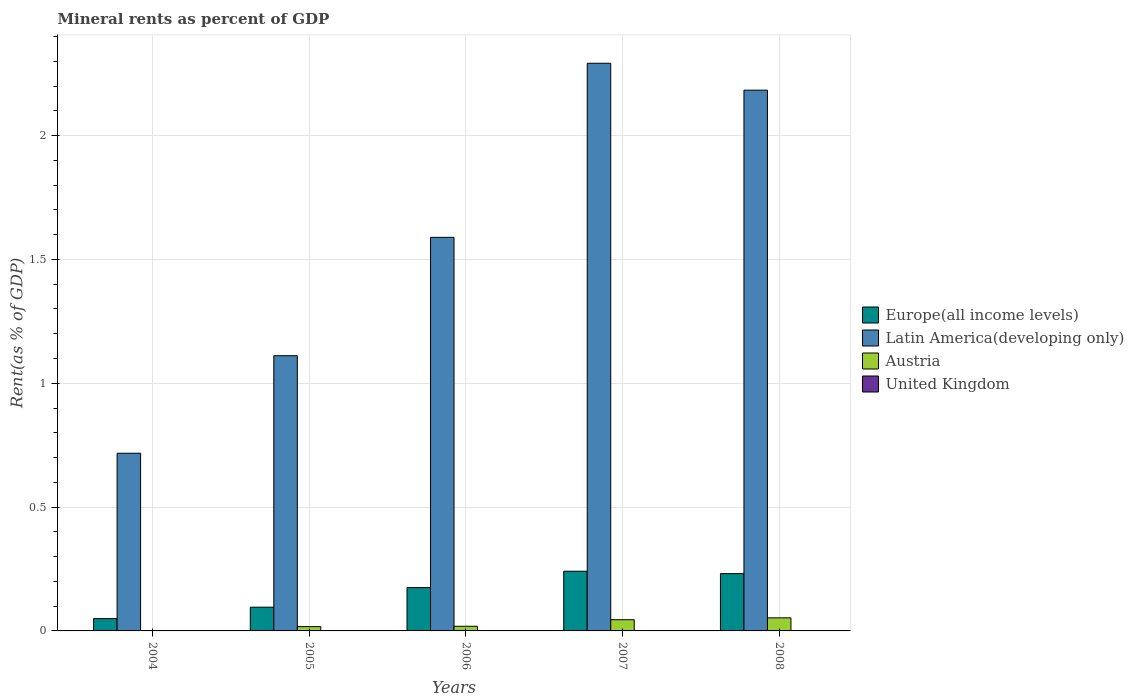How many groups of bars are there?
Give a very brief answer. 5. Are the number of bars on each tick of the X-axis equal?
Provide a succinct answer. Yes. How many bars are there on the 4th tick from the left?
Make the answer very short. 4. How many bars are there on the 2nd tick from the right?
Provide a succinct answer. 4. What is the label of the 4th group of bars from the left?
Provide a succinct answer. 2007. What is the mineral rent in Austria in 2004?
Provide a short and direct response. 0. Across all years, what is the maximum mineral rent in United Kingdom?
Give a very brief answer. 0. Across all years, what is the minimum mineral rent in Latin America(developing only)?
Your answer should be compact. 0.72. In which year was the mineral rent in Latin America(developing only) maximum?
Your answer should be compact. 2007. What is the total mineral rent in Austria in the graph?
Offer a very short reply. 0.13. What is the difference between the mineral rent in United Kingdom in 2005 and that in 2008?
Your answer should be very brief. -0. What is the difference between the mineral rent in United Kingdom in 2008 and the mineral rent in Latin America(developing only) in 2004?
Offer a very short reply. -0.72. What is the average mineral rent in United Kingdom per year?
Your answer should be very brief. 3.6004656542504624e-5. In the year 2007, what is the difference between the mineral rent in Europe(all income levels) and mineral rent in Latin America(developing only)?
Make the answer very short. -2.05. What is the ratio of the mineral rent in Latin America(developing only) in 2004 to that in 2006?
Offer a terse response. 0.45. What is the difference between the highest and the second highest mineral rent in Europe(all income levels)?
Provide a succinct answer. 0.01. What is the difference between the highest and the lowest mineral rent in Europe(all income levels)?
Offer a terse response. 0.19. Is the sum of the mineral rent in United Kingdom in 2004 and 2005 greater than the maximum mineral rent in Europe(all income levels) across all years?
Make the answer very short. No. What does the 1st bar from the left in 2008 represents?
Your response must be concise. Europe(all income levels). What does the 4th bar from the right in 2006 represents?
Offer a terse response. Europe(all income levels). How many bars are there?
Provide a succinct answer. 20. How many years are there in the graph?
Your answer should be very brief. 5. Are the values on the major ticks of Y-axis written in scientific E-notation?
Provide a short and direct response. No. Does the graph contain any zero values?
Your response must be concise. No. Where does the legend appear in the graph?
Make the answer very short. Center right. How many legend labels are there?
Your response must be concise. 4. How are the legend labels stacked?
Offer a terse response. Vertical. What is the title of the graph?
Provide a short and direct response. Mineral rents as percent of GDP. Does "Australia" appear as one of the legend labels in the graph?
Offer a terse response. No. What is the label or title of the X-axis?
Your answer should be very brief. Years. What is the label or title of the Y-axis?
Offer a very short reply. Rent(as % of GDP). What is the Rent(as % of GDP) of Europe(all income levels) in 2004?
Ensure brevity in your answer.  0.05. What is the Rent(as % of GDP) in Latin America(developing only) in 2004?
Your response must be concise. 0.72. What is the Rent(as % of GDP) of Austria in 2004?
Make the answer very short. 0. What is the Rent(as % of GDP) of United Kingdom in 2004?
Provide a succinct answer. 6.19596915094659e-6. What is the Rent(as % of GDP) in Europe(all income levels) in 2005?
Ensure brevity in your answer.  0.1. What is the Rent(as % of GDP) of Latin America(developing only) in 2005?
Give a very brief answer. 1.11. What is the Rent(as % of GDP) in Austria in 2005?
Provide a short and direct response. 0.02. What is the Rent(as % of GDP) in United Kingdom in 2005?
Your answer should be very brief. 7.34291393954371e-6. What is the Rent(as % of GDP) in Europe(all income levels) in 2006?
Your answer should be very brief. 0.18. What is the Rent(as % of GDP) of Latin America(developing only) in 2006?
Make the answer very short. 1.59. What is the Rent(as % of GDP) of Austria in 2006?
Make the answer very short. 0.02. What is the Rent(as % of GDP) of United Kingdom in 2006?
Make the answer very short. 1.26189468360093e-5. What is the Rent(as % of GDP) in Europe(all income levels) in 2007?
Offer a terse response. 0.24. What is the Rent(as % of GDP) of Latin America(developing only) in 2007?
Your answer should be very brief. 2.29. What is the Rent(as % of GDP) in Austria in 2007?
Your answer should be very brief. 0.05. What is the Rent(as % of GDP) of United Kingdom in 2007?
Offer a terse response. 3.21125777650235e-5. What is the Rent(as % of GDP) in Europe(all income levels) in 2008?
Ensure brevity in your answer.  0.23. What is the Rent(as % of GDP) in Latin America(developing only) in 2008?
Your answer should be very brief. 2.18. What is the Rent(as % of GDP) in Austria in 2008?
Keep it short and to the point. 0.05. What is the Rent(as % of GDP) of United Kingdom in 2008?
Your answer should be compact. 0. Across all years, what is the maximum Rent(as % of GDP) of Europe(all income levels)?
Offer a terse response. 0.24. Across all years, what is the maximum Rent(as % of GDP) of Latin America(developing only)?
Your response must be concise. 2.29. Across all years, what is the maximum Rent(as % of GDP) of Austria?
Your answer should be compact. 0.05. Across all years, what is the maximum Rent(as % of GDP) of United Kingdom?
Make the answer very short. 0. Across all years, what is the minimum Rent(as % of GDP) of Europe(all income levels)?
Offer a very short reply. 0.05. Across all years, what is the minimum Rent(as % of GDP) in Latin America(developing only)?
Offer a very short reply. 0.72. Across all years, what is the minimum Rent(as % of GDP) in Austria?
Ensure brevity in your answer.  0. Across all years, what is the minimum Rent(as % of GDP) of United Kingdom?
Keep it short and to the point. 6.19596915094659e-6. What is the total Rent(as % of GDP) of Europe(all income levels) in the graph?
Make the answer very short. 0.79. What is the total Rent(as % of GDP) in Latin America(developing only) in the graph?
Your answer should be very brief. 7.89. What is the total Rent(as % of GDP) of Austria in the graph?
Your answer should be compact. 0.13. What is the difference between the Rent(as % of GDP) in Europe(all income levels) in 2004 and that in 2005?
Offer a very short reply. -0.05. What is the difference between the Rent(as % of GDP) of Latin America(developing only) in 2004 and that in 2005?
Offer a very short reply. -0.39. What is the difference between the Rent(as % of GDP) of Austria in 2004 and that in 2005?
Provide a succinct answer. -0.02. What is the difference between the Rent(as % of GDP) of Europe(all income levels) in 2004 and that in 2006?
Offer a very short reply. -0.13. What is the difference between the Rent(as % of GDP) of Latin America(developing only) in 2004 and that in 2006?
Your response must be concise. -0.87. What is the difference between the Rent(as % of GDP) in Austria in 2004 and that in 2006?
Your answer should be compact. -0.02. What is the difference between the Rent(as % of GDP) of United Kingdom in 2004 and that in 2006?
Your response must be concise. -0. What is the difference between the Rent(as % of GDP) of Europe(all income levels) in 2004 and that in 2007?
Give a very brief answer. -0.19. What is the difference between the Rent(as % of GDP) of Latin America(developing only) in 2004 and that in 2007?
Offer a very short reply. -1.57. What is the difference between the Rent(as % of GDP) in Austria in 2004 and that in 2007?
Give a very brief answer. -0.04. What is the difference between the Rent(as % of GDP) in United Kingdom in 2004 and that in 2007?
Provide a succinct answer. -0. What is the difference between the Rent(as % of GDP) of Europe(all income levels) in 2004 and that in 2008?
Your answer should be compact. -0.18. What is the difference between the Rent(as % of GDP) in Latin America(developing only) in 2004 and that in 2008?
Your answer should be compact. -1.47. What is the difference between the Rent(as % of GDP) in Austria in 2004 and that in 2008?
Your response must be concise. -0.05. What is the difference between the Rent(as % of GDP) in United Kingdom in 2004 and that in 2008?
Provide a short and direct response. -0. What is the difference between the Rent(as % of GDP) of Europe(all income levels) in 2005 and that in 2006?
Your answer should be very brief. -0.08. What is the difference between the Rent(as % of GDP) in Latin America(developing only) in 2005 and that in 2006?
Offer a very short reply. -0.48. What is the difference between the Rent(as % of GDP) in Austria in 2005 and that in 2006?
Your answer should be very brief. -0. What is the difference between the Rent(as % of GDP) in Europe(all income levels) in 2005 and that in 2007?
Offer a terse response. -0.15. What is the difference between the Rent(as % of GDP) in Latin America(developing only) in 2005 and that in 2007?
Your answer should be very brief. -1.18. What is the difference between the Rent(as % of GDP) of Austria in 2005 and that in 2007?
Ensure brevity in your answer.  -0.03. What is the difference between the Rent(as % of GDP) in Europe(all income levels) in 2005 and that in 2008?
Your answer should be compact. -0.14. What is the difference between the Rent(as % of GDP) in Latin America(developing only) in 2005 and that in 2008?
Provide a succinct answer. -1.07. What is the difference between the Rent(as % of GDP) of Austria in 2005 and that in 2008?
Your answer should be compact. -0.04. What is the difference between the Rent(as % of GDP) in United Kingdom in 2005 and that in 2008?
Ensure brevity in your answer.  -0. What is the difference between the Rent(as % of GDP) in Europe(all income levels) in 2006 and that in 2007?
Provide a succinct answer. -0.07. What is the difference between the Rent(as % of GDP) in Latin America(developing only) in 2006 and that in 2007?
Offer a very short reply. -0.7. What is the difference between the Rent(as % of GDP) of Austria in 2006 and that in 2007?
Offer a very short reply. -0.03. What is the difference between the Rent(as % of GDP) in Europe(all income levels) in 2006 and that in 2008?
Give a very brief answer. -0.06. What is the difference between the Rent(as % of GDP) of Latin America(developing only) in 2006 and that in 2008?
Ensure brevity in your answer.  -0.59. What is the difference between the Rent(as % of GDP) in Austria in 2006 and that in 2008?
Ensure brevity in your answer.  -0.03. What is the difference between the Rent(as % of GDP) of United Kingdom in 2006 and that in 2008?
Provide a succinct answer. -0. What is the difference between the Rent(as % of GDP) in Europe(all income levels) in 2007 and that in 2008?
Offer a very short reply. 0.01. What is the difference between the Rent(as % of GDP) in Latin America(developing only) in 2007 and that in 2008?
Provide a short and direct response. 0.11. What is the difference between the Rent(as % of GDP) of Austria in 2007 and that in 2008?
Provide a succinct answer. -0.01. What is the difference between the Rent(as % of GDP) of United Kingdom in 2007 and that in 2008?
Give a very brief answer. -0. What is the difference between the Rent(as % of GDP) in Europe(all income levels) in 2004 and the Rent(as % of GDP) in Latin America(developing only) in 2005?
Ensure brevity in your answer.  -1.06. What is the difference between the Rent(as % of GDP) of Europe(all income levels) in 2004 and the Rent(as % of GDP) of Austria in 2005?
Offer a very short reply. 0.03. What is the difference between the Rent(as % of GDP) of Europe(all income levels) in 2004 and the Rent(as % of GDP) of United Kingdom in 2005?
Provide a succinct answer. 0.05. What is the difference between the Rent(as % of GDP) of Latin America(developing only) in 2004 and the Rent(as % of GDP) of Austria in 2005?
Your answer should be compact. 0.7. What is the difference between the Rent(as % of GDP) in Latin America(developing only) in 2004 and the Rent(as % of GDP) in United Kingdom in 2005?
Provide a short and direct response. 0.72. What is the difference between the Rent(as % of GDP) in Europe(all income levels) in 2004 and the Rent(as % of GDP) in Latin America(developing only) in 2006?
Keep it short and to the point. -1.54. What is the difference between the Rent(as % of GDP) of Europe(all income levels) in 2004 and the Rent(as % of GDP) of Austria in 2006?
Ensure brevity in your answer.  0.03. What is the difference between the Rent(as % of GDP) in Europe(all income levels) in 2004 and the Rent(as % of GDP) in United Kingdom in 2006?
Offer a very short reply. 0.05. What is the difference between the Rent(as % of GDP) of Latin America(developing only) in 2004 and the Rent(as % of GDP) of Austria in 2006?
Your response must be concise. 0.7. What is the difference between the Rent(as % of GDP) in Latin America(developing only) in 2004 and the Rent(as % of GDP) in United Kingdom in 2006?
Keep it short and to the point. 0.72. What is the difference between the Rent(as % of GDP) in Europe(all income levels) in 2004 and the Rent(as % of GDP) in Latin America(developing only) in 2007?
Your answer should be very brief. -2.24. What is the difference between the Rent(as % of GDP) in Europe(all income levels) in 2004 and the Rent(as % of GDP) in Austria in 2007?
Offer a terse response. 0. What is the difference between the Rent(as % of GDP) of Europe(all income levels) in 2004 and the Rent(as % of GDP) of United Kingdom in 2007?
Offer a very short reply. 0.05. What is the difference between the Rent(as % of GDP) in Latin America(developing only) in 2004 and the Rent(as % of GDP) in Austria in 2007?
Give a very brief answer. 0.67. What is the difference between the Rent(as % of GDP) of Latin America(developing only) in 2004 and the Rent(as % of GDP) of United Kingdom in 2007?
Keep it short and to the point. 0.72. What is the difference between the Rent(as % of GDP) in Europe(all income levels) in 2004 and the Rent(as % of GDP) in Latin America(developing only) in 2008?
Your answer should be compact. -2.13. What is the difference between the Rent(as % of GDP) of Europe(all income levels) in 2004 and the Rent(as % of GDP) of Austria in 2008?
Keep it short and to the point. -0. What is the difference between the Rent(as % of GDP) in Europe(all income levels) in 2004 and the Rent(as % of GDP) in United Kingdom in 2008?
Ensure brevity in your answer.  0.05. What is the difference between the Rent(as % of GDP) in Latin America(developing only) in 2004 and the Rent(as % of GDP) in Austria in 2008?
Your response must be concise. 0.66. What is the difference between the Rent(as % of GDP) of Latin America(developing only) in 2004 and the Rent(as % of GDP) of United Kingdom in 2008?
Your answer should be very brief. 0.72. What is the difference between the Rent(as % of GDP) in Austria in 2004 and the Rent(as % of GDP) in United Kingdom in 2008?
Ensure brevity in your answer.  0. What is the difference between the Rent(as % of GDP) in Europe(all income levels) in 2005 and the Rent(as % of GDP) in Latin America(developing only) in 2006?
Offer a terse response. -1.49. What is the difference between the Rent(as % of GDP) of Europe(all income levels) in 2005 and the Rent(as % of GDP) of Austria in 2006?
Ensure brevity in your answer.  0.08. What is the difference between the Rent(as % of GDP) of Europe(all income levels) in 2005 and the Rent(as % of GDP) of United Kingdom in 2006?
Provide a succinct answer. 0.1. What is the difference between the Rent(as % of GDP) in Latin America(developing only) in 2005 and the Rent(as % of GDP) in Austria in 2006?
Keep it short and to the point. 1.09. What is the difference between the Rent(as % of GDP) of Latin America(developing only) in 2005 and the Rent(as % of GDP) of United Kingdom in 2006?
Provide a succinct answer. 1.11. What is the difference between the Rent(as % of GDP) in Austria in 2005 and the Rent(as % of GDP) in United Kingdom in 2006?
Your response must be concise. 0.02. What is the difference between the Rent(as % of GDP) of Europe(all income levels) in 2005 and the Rent(as % of GDP) of Latin America(developing only) in 2007?
Keep it short and to the point. -2.2. What is the difference between the Rent(as % of GDP) in Europe(all income levels) in 2005 and the Rent(as % of GDP) in Austria in 2007?
Keep it short and to the point. 0.05. What is the difference between the Rent(as % of GDP) of Europe(all income levels) in 2005 and the Rent(as % of GDP) of United Kingdom in 2007?
Provide a succinct answer. 0.1. What is the difference between the Rent(as % of GDP) of Latin America(developing only) in 2005 and the Rent(as % of GDP) of Austria in 2007?
Your response must be concise. 1.07. What is the difference between the Rent(as % of GDP) of Latin America(developing only) in 2005 and the Rent(as % of GDP) of United Kingdom in 2007?
Provide a succinct answer. 1.11. What is the difference between the Rent(as % of GDP) in Austria in 2005 and the Rent(as % of GDP) in United Kingdom in 2007?
Offer a terse response. 0.02. What is the difference between the Rent(as % of GDP) of Europe(all income levels) in 2005 and the Rent(as % of GDP) of Latin America(developing only) in 2008?
Offer a very short reply. -2.09. What is the difference between the Rent(as % of GDP) in Europe(all income levels) in 2005 and the Rent(as % of GDP) in Austria in 2008?
Give a very brief answer. 0.04. What is the difference between the Rent(as % of GDP) of Europe(all income levels) in 2005 and the Rent(as % of GDP) of United Kingdom in 2008?
Make the answer very short. 0.1. What is the difference between the Rent(as % of GDP) in Latin America(developing only) in 2005 and the Rent(as % of GDP) in Austria in 2008?
Provide a succinct answer. 1.06. What is the difference between the Rent(as % of GDP) of Austria in 2005 and the Rent(as % of GDP) of United Kingdom in 2008?
Offer a terse response. 0.02. What is the difference between the Rent(as % of GDP) in Europe(all income levels) in 2006 and the Rent(as % of GDP) in Latin America(developing only) in 2007?
Offer a terse response. -2.12. What is the difference between the Rent(as % of GDP) in Europe(all income levels) in 2006 and the Rent(as % of GDP) in Austria in 2007?
Give a very brief answer. 0.13. What is the difference between the Rent(as % of GDP) in Europe(all income levels) in 2006 and the Rent(as % of GDP) in United Kingdom in 2007?
Offer a very short reply. 0.17. What is the difference between the Rent(as % of GDP) of Latin America(developing only) in 2006 and the Rent(as % of GDP) of Austria in 2007?
Offer a very short reply. 1.54. What is the difference between the Rent(as % of GDP) in Latin America(developing only) in 2006 and the Rent(as % of GDP) in United Kingdom in 2007?
Offer a terse response. 1.59. What is the difference between the Rent(as % of GDP) in Austria in 2006 and the Rent(as % of GDP) in United Kingdom in 2007?
Keep it short and to the point. 0.02. What is the difference between the Rent(as % of GDP) of Europe(all income levels) in 2006 and the Rent(as % of GDP) of Latin America(developing only) in 2008?
Your answer should be compact. -2.01. What is the difference between the Rent(as % of GDP) of Europe(all income levels) in 2006 and the Rent(as % of GDP) of Austria in 2008?
Make the answer very short. 0.12. What is the difference between the Rent(as % of GDP) of Europe(all income levels) in 2006 and the Rent(as % of GDP) of United Kingdom in 2008?
Provide a succinct answer. 0.17. What is the difference between the Rent(as % of GDP) in Latin America(developing only) in 2006 and the Rent(as % of GDP) in Austria in 2008?
Your response must be concise. 1.54. What is the difference between the Rent(as % of GDP) in Latin America(developing only) in 2006 and the Rent(as % of GDP) in United Kingdom in 2008?
Offer a very short reply. 1.59. What is the difference between the Rent(as % of GDP) of Austria in 2006 and the Rent(as % of GDP) of United Kingdom in 2008?
Ensure brevity in your answer.  0.02. What is the difference between the Rent(as % of GDP) of Europe(all income levels) in 2007 and the Rent(as % of GDP) of Latin America(developing only) in 2008?
Provide a succinct answer. -1.94. What is the difference between the Rent(as % of GDP) of Europe(all income levels) in 2007 and the Rent(as % of GDP) of Austria in 2008?
Your response must be concise. 0.19. What is the difference between the Rent(as % of GDP) in Europe(all income levels) in 2007 and the Rent(as % of GDP) in United Kingdom in 2008?
Offer a terse response. 0.24. What is the difference between the Rent(as % of GDP) in Latin America(developing only) in 2007 and the Rent(as % of GDP) in Austria in 2008?
Your answer should be compact. 2.24. What is the difference between the Rent(as % of GDP) of Latin America(developing only) in 2007 and the Rent(as % of GDP) of United Kingdom in 2008?
Your response must be concise. 2.29. What is the difference between the Rent(as % of GDP) in Austria in 2007 and the Rent(as % of GDP) in United Kingdom in 2008?
Offer a terse response. 0.05. What is the average Rent(as % of GDP) in Europe(all income levels) per year?
Ensure brevity in your answer.  0.16. What is the average Rent(as % of GDP) of Latin America(developing only) per year?
Offer a terse response. 1.58. What is the average Rent(as % of GDP) of Austria per year?
Your answer should be very brief. 0.03. What is the average Rent(as % of GDP) of United Kingdom per year?
Offer a terse response. 0. In the year 2004, what is the difference between the Rent(as % of GDP) in Europe(all income levels) and Rent(as % of GDP) in Latin America(developing only)?
Your response must be concise. -0.67. In the year 2004, what is the difference between the Rent(as % of GDP) in Europe(all income levels) and Rent(as % of GDP) in Austria?
Ensure brevity in your answer.  0.05. In the year 2004, what is the difference between the Rent(as % of GDP) of Europe(all income levels) and Rent(as % of GDP) of United Kingdom?
Your answer should be very brief. 0.05. In the year 2004, what is the difference between the Rent(as % of GDP) in Latin America(developing only) and Rent(as % of GDP) in Austria?
Keep it short and to the point. 0.72. In the year 2004, what is the difference between the Rent(as % of GDP) in Latin America(developing only) and Rent(as % of GDP) in United Kingdom?
Offer a terse response. 0.72. In the year 2005, what is the difference between the Rent(as % of GDP) of Europe(all income levels) and Rent(as % of GDP) of Latin America(developing only)?
Keep it short and to the point. -1.02. In the year 2005, what is the difference between the Rent(as % of GDP) of Europe(all income levels) and Rent(as % of GDP) of Austria?
Offer a terse response. 0.08. In the year 2005, what is the difference between the Rent(as % of GDP) of Europe(all income levels) and Rent(as % of GDP) of United Kingdom?
Give a very brief answer. 0.1. In the year 2005, what is the difference between the Rent(as % of GDP) of Latin America(developing only) and Rent(as % of GDP) of Austria?
Provide a short and direct response. 1.09. In the year 2005, what is the difference between the Rent(as % of GDP) in Latin America(developing only) and Rent(as % of GDP) in United Kingdom?
Offer a terse response. 1.11. In the year 2005, what is the difference between the Rent(as % of GDP) of Austria and Rent(as % of GDP) of United Kingdom?
Keep it short and to the point. 0.02. In the year 2006, what is the difference between the Rent(as % of GDP) of Europe(all income levels) and Rent(as % of GDP) of Latin America(developing only)?
Offer a very short reply. -1.41. In the year 2006, what is the difference between the Rent(as % of GDP) in Europe(all income levels) and Rent(as % of GDP) in Austria?
Your response must be concise. 0.16. In the year 2006, what is the difference between the Rent(as % of GDP) of Europe(all income levels) and Rent(as % of GDP) of United Kingdom?
Offer a terse response. 0.17. In the year 2006, what is the difference between the Rent(as % of GDP) of Latin America(developing only) and Rent(as % of GDP) of Austria?
Give a very brief answer. 1.57. In the year 2006, what is the difference between the Rent(as % of GDP) of Latin America(developing only) and Rent(as % of GDP) of United Kingdom?
Provide a succinct answer. 1.59. In the year 2006, what is the difference between the Rent(as % of GDP) in Austria and Rent(as % of GDP) in United Kingdom?
Provide a succinct answer. 0.02. In the year 2007, what is the difference between the Rent(as % of GDP) of Europe(all income levels) and Rent(as % of GDP) of Latin America(developing only)?
Your response must be concise. -2.05. In the year 2007, what is the difference between the Rent(as % of GDP) in Europe(all income levels) and Rent(as % of GDP) in Austria?
Provide a succinct answer. 0.2. In the year 2007, what is the difference between the Rent(as % of GDP) in Europe(all income levels) and Rent(as % of GDP) in United Kingdom?
Make the answer very short. 0.24. In the year 2007, what is the difference between the Rent(as % of GDP) of Latin America(developing only) and Rent(as % of GDP) of Austria?
Ensure brevity in your answer.  2.25. In the year 2007, what is the difference between the Rent(as % of GDP) in Latin America(developing only) and Rent(as % of GDP) in United Kingdom?
Offer a terse response. 2.29. In the year 2007, what is the difference between the Rent(as % of GDP) in Austria and Rent(as % of GDP) in United Kingdom?
Your response must be concise. 0.05. In the year 2008, what is the difference between the Rent(as % of GDP) in Europe(all income levels) and Rent(as % of GDP) in Latin America(developing only)?
Your response must be concise. -1.95. In the year 2008, what is the difference between the Rent(as % of GDP) of Europe(all income levels) and Rent(as % of GDP) of Austria?
Provide a short and direct response. 0.18. In the year 2008, what is the difference between the Rent(as % of GDP) of Europe(all income levels) and Rent(as % of GDP) of United Kingdom?
Your answer should be very brief. 0.23. In the year 2008, what is the difference between the Rent(as % of GDP) in Latin America(developing only) and Rent(as % of GDP) in Austria?
Keep it short and to the point. 2.13. In the year 2008, what is the difference between the Rent(as % of GDP) of Latin America(developing only) and Rent(as % of GDP) of United Kingdom?
Keep it short and to the point. 2.18. In the year 2008, what is the difference between the Rent(as % of GDP) in Austria and Rent(as % of GDP) in United Kingdom?
Give a very brief answer. 0.05. What is the ratio of the Rent(as % of GDP) in Europe(all income levels) in 2004 to that in 2005?
Ensure brevity in your answer.  0.52. What is the ratio of the Rent(as % of GDP) in Latin America(developing only) in 2004 to that in 2005?
Give a very brief answer. 0.65. What is the ratio of the Rent(as % of GDP) in Austria in 2004 to that in 2005?
Your response must be concise. 0.02. What is the ratio of the Rent(as % of GDP) in United Kingdom in 2004 to that in 2005?
Offer a very short reply. 0.84. What is the ratio of the Rent(as % of GDP) of Europe(all income levels) in 2004 to that in 2006?
Make the answer very short. 0.28. What is the ratio of the Rent(as % of GDP) in Latin America(developing only) in 2004 to that in 2006?
Your answer should be very brief. 0.45. What is the ratio of the Rent(as % of GDP) in Austria in 2004 to that in 2006?
Give a very brief answer. 0.02. What is the ratio of the Rent(as % of GDP) in United Kingdom in 2004 to that in 2006?
Offer a very short reply. 0.49. What is the ratio of the Rent(as % of GDP) in Europe(all income levels) in 2004 to that in 2007?
Offer a terse response. 0.21. What is the ratio of the Rent(as % of GDP) in Latin America(developing only) in 2004 to that in 2007?
Offer a terse response. 0.31. What is the ratio of the Rent(as % of GDP) in Austria in 2004 to that in 2007?
Provide a succinct answer. 0.01. What is the ratio of the Rent(as % of GDP) of United Kingdom in 2004 to that in 2007?
Your answer should be very brief. 0.19. What is the ratio of the Rent(as % of GDP) in Europe(all income levels) in 2004 to that in 2008?
Provide a short and direct response. 0.22. What is the ratio of the Rent(as % of GDP) in Latin America(developing only) in 2004 to that in 2008?
Offer a very short reply. 0.33. What is the ratio of the Rent(as % of GDP) in Austria in 2004 to that in 2008?
Give a very brief answer. 0.01. What is the ratio of the Rent(as % of GDP) in United Kingdom in 2004 to that in 2008?
Your answer should be compact. 0.05. What is the ratio of the Rent(as % of GDP) of Europe(all income levels) in 2005 to that in 2006?
Give a very brief answer. 0.55. What is the ratio of the Rent(as % of GDP) in Latin America(developing only) in 2005 to that in 2006?
Your answer should be compact. 0.7. What is the ratio of the Rent(as % of GDP) in Austria in 2005 to that in 2006?
Provide a succinct answer. 0.92. What is the ratio of the Rent(as % of GDP) in United Kingdom in 2005 to that in 2006?
Offer a very short reply. 0.58. What is the ratio of the Rent(as % of GDP) in Europe(all income levels) in 2005 to that in 2007?
Provide a short and direct response. 0.4. What is the ratio of the Rent(as % of GDP) of Latin America(developing only) in 2005 to that in 2007?
Keep it short and to the point. 0.48. What is the ratio of the Rent(as % of GDP) in Austria in 2005 to that in 2007?
Give a very brief answer. 0.38. What is the ratio of the Rent(as % of GDP) in United Kingdom in 2005 to that in 2007?
Your response must be concise. 0.23. What is the ratio of the Rent(as % of GDP) in Europe(all income levels) in 2005 to that in 2008?
Your response must be concise. 0.41. What is the ratio of the Rent(as % of GDP) in Latin America(developing only) in 2005 to that in 2008?
Offer a very short reply. 0.51. What is the ratio of the Rent(as % of GDP) of Austria in 2005 to that in 2008?
Your answer should be compact. 0.33. What is the ratio of the Rent(as % of GDP) of United Kingdom in 2005 to that in 2008?
Your answer should be compact. 0.06. What is the ratio of the Rent(as % of GDP) in Europe(all income levels) in 2006 to that in 2007?
Offer a very short reply. 0.73. What is the ratio of the Rent(as % of GDP) in Latin America(developing only) in 2006 to that in 2007?
Keep it short and to the point. 0.69. What is the ratio of the Rent(as % of GDP) of Austria in 2006 to that in 2007?
Keep it short and to the point. 0.41. What is the ratio of the Rent(as % of GDP) of United Kingdom in 2006 to that in 2007?
Your answer should be very brief. 0.39. What is the ratio of the Rent(as % of GDP) of Europe(all income levels) in 2006 to that in 2008?
Provide a short and direct response. 0.76. What is the ratio of the Rent(as % of GDP) of Latin America(developing only) in 2006 to that in 2008?
Provide a short and direct response. 0.73. What is the ratio of the Rent(as % of GDP) of Austria in 2006 to that in 2008?
Provide a short and direct response. 0.36. What is the ratio of the Rent(as % of GDP) of United Kingdom in 2006 to that in 2008?
Offer a terse response. 0.1. What is the ratio of the Rent(as % of GDP) in Europe(all income levels) in 2007 to that in 2008?
Your answer should be very brief. 1.04. What is the ratio of the Rent(as % of GDP) of Latin America(developing only) in 2007 to that in 2008?
Provide a short and direct response. 1.05. What is the ratio of the Rent(as % of GDP) of Austria in 2007 to that in 2008?
Give a very brief answer. 0.86. What is the ratio of the Rent(as % of GDP) in United Kingdom in 2007 to that in 2008?
Ensure brevity in your answer.  0.26. What is the difference between the highest and the second highest Rent(as % of GDP) in Europe(all income levels)?
Your answer should be compact. 0.01. What is the difference between the highest and the second highest Rent(as % of GDP) of Latin America(developing only)?
Offer a terse response. 0.11. What is the difference between the highest and the second highest Rent(as % of GDP) of Austria?
Make the answer very short. 0.01. What is the difference between the highest and the second highest Rent(as % of GDP) in United Kingdom?
Your answer should be compact. 0. What is the difference between the highest and the lowest Rent(as % of GDP) of Europe(all income levels)?
Your response must be concise. 0.19. What is the difference between the highest and the lowest Rent(as % of GDP) in Latin America(developing only)?
Provide a succinct answer. 1.57. What is the difference between the highest and the lowest Rent(as % of GDP) of Austria?
Offer a very short reply. 0.05. What is the difference between the highest and the lowest Rent(as % of GDP) in United Kingdom?
Provide a succinct answer. 0. 